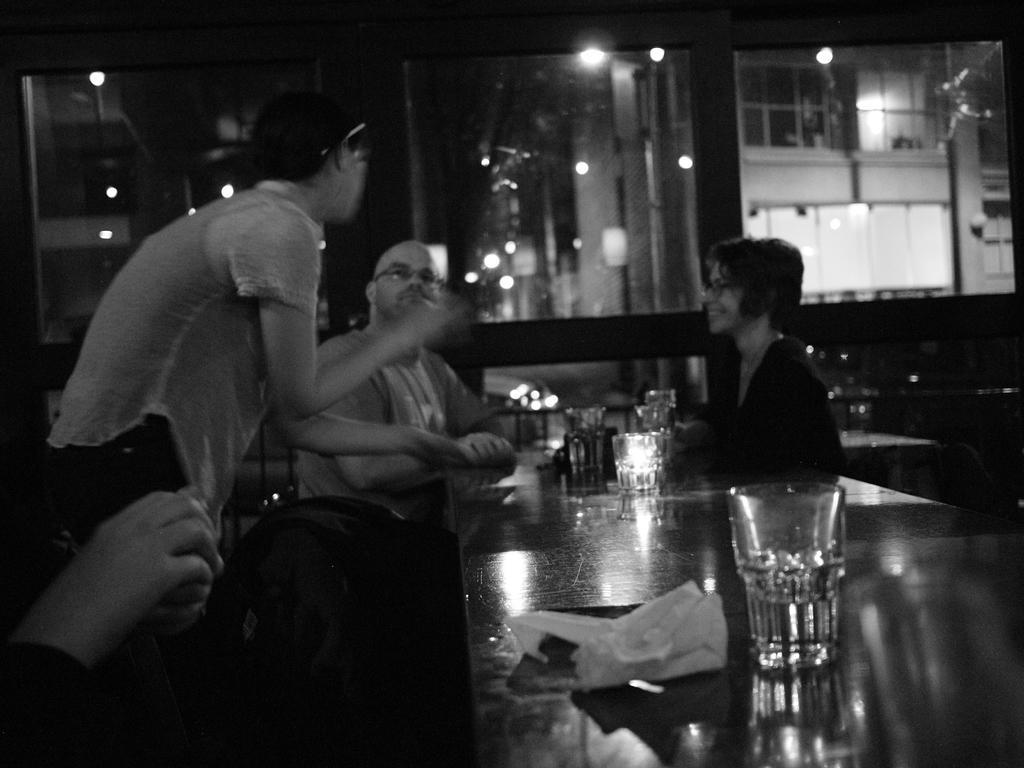Please provide a concise description of this image. in this image some person are sitting on the table and some table and chairs are present in the room some glasses are also present on the table and some paper also there on the table and they could be talking each other and another person is standing but he is not visible the only hand should be visible 